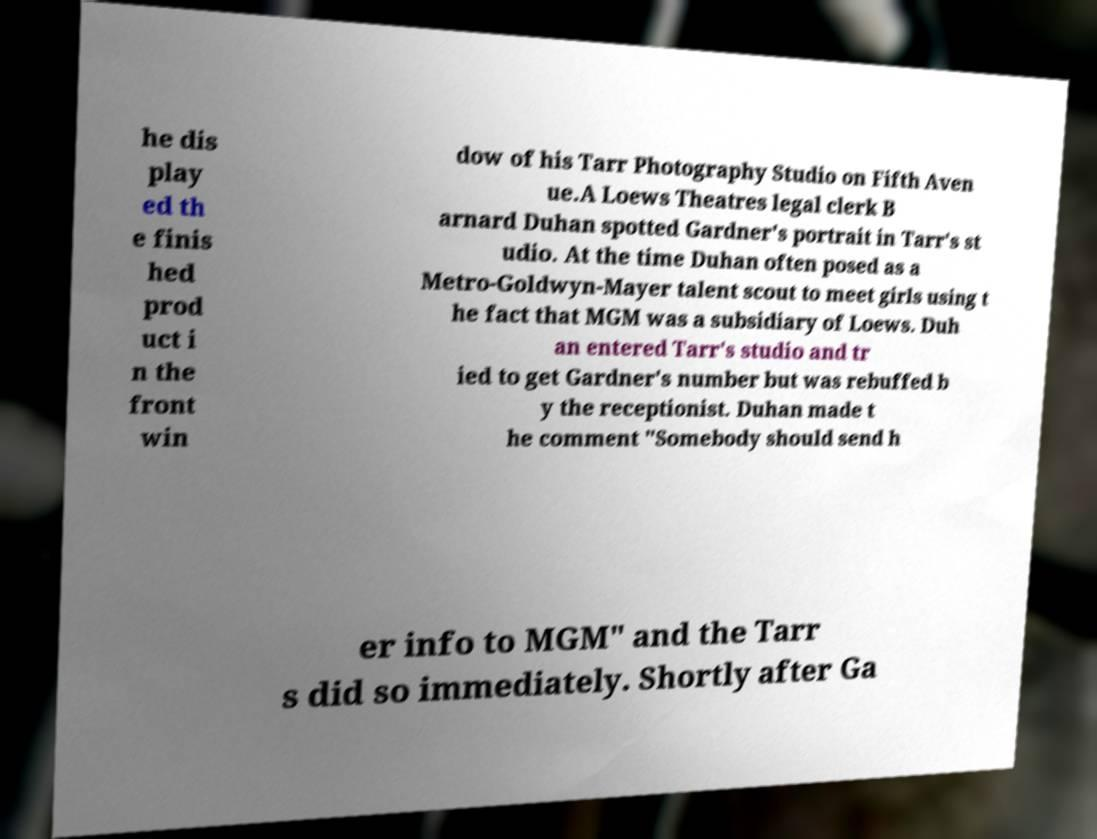Please identify and transcribe the text found in this image. he dis play ed th e finis hed prod uct i n the front win dow of his Tarr Photography Studio on Fifth Aven ue.A Loews Theatres legal clerk B arnard Duhan spotted Gardner's portrait in Tarr's st udio. At the time Duhan often posed as a Metro-Goldwyn-Mayer talent scout to meet girls using t he fact that MGM was a subsidiary of Loews. Duh an entered Tarr's studio and tr ied to get Gardner's number but was rebuffed b y the receptionist. Duhan made t he comment "Somebody should send h er info to MGM" and the Tarr s did so immediately. Shortly after Ga 